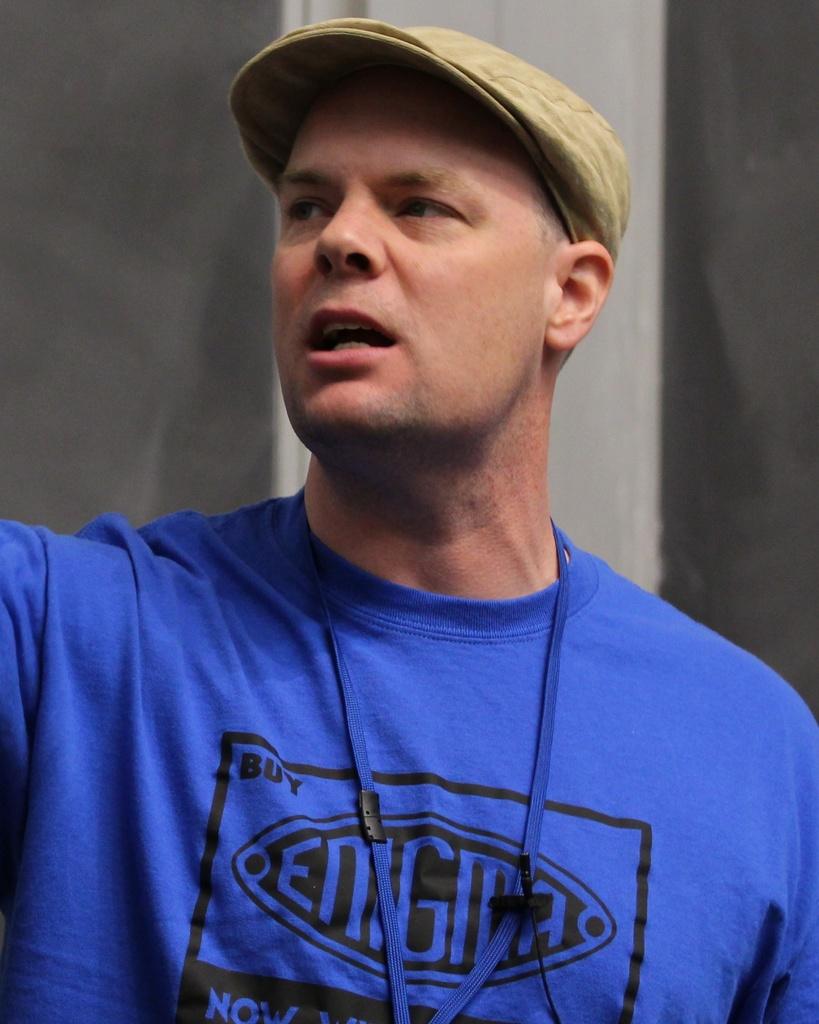What is the brand of the blue shirt?
Your answer should be compact. Enigma. According to the shirt, should you buy or sell ?
Make the answer very short. Buy. 